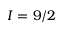Convert formula to latex. <formula><loc_0><loc_0><loc_500><loc_500>I = 9 / 2</formula> 